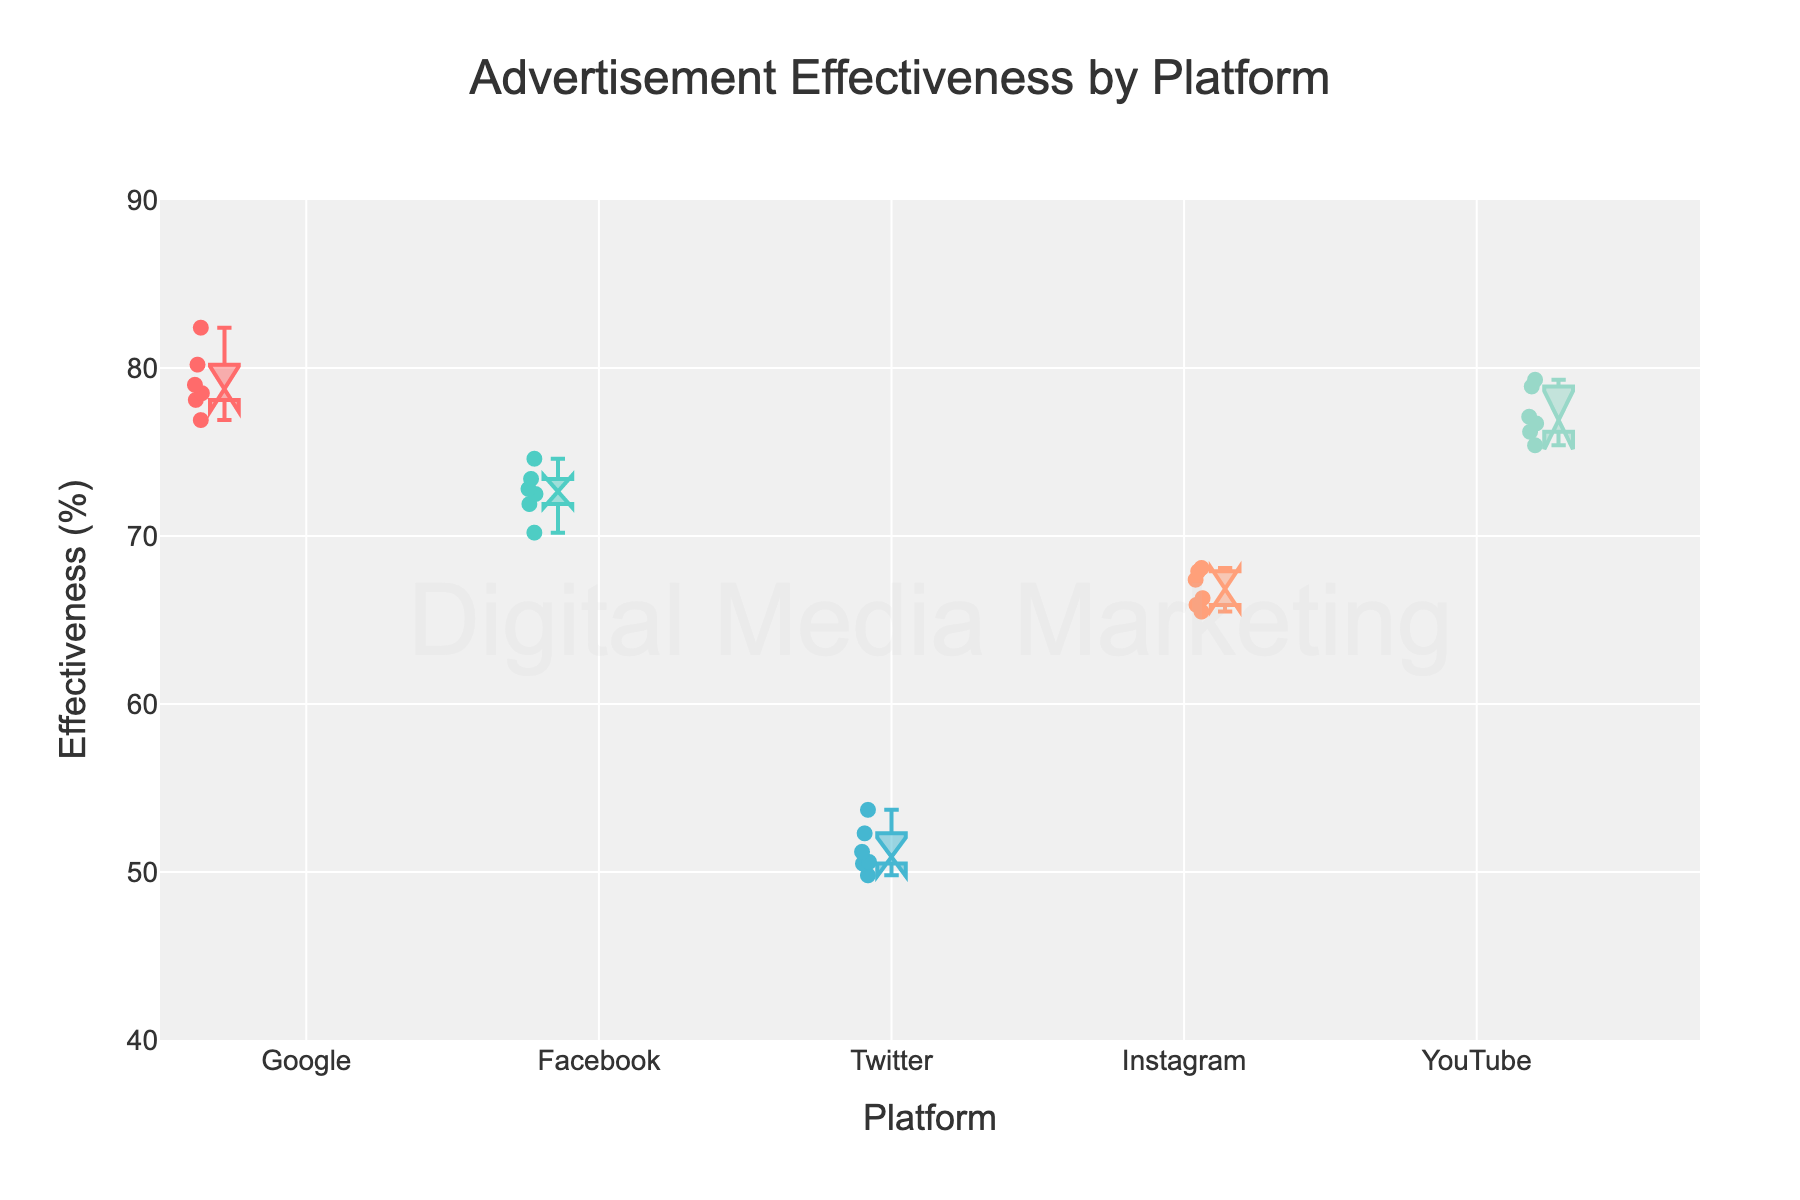Which platform has the highest median effectiveness? To identify the highest median effectiveness, look at the notches in the box plots. The notch represents the median. The platform with the highest notch is Google.
Answer: Google What is the range of effectiveness for Twitter? To find the range, look at the box plot for Twitter. The top whisker represents the maximum value, and the bottom whisker represents the minimum value. For Twitter, the minimum is approximately 49.8%, and the maximum is approximately 53.7%. Thus, the range is 53.7% - 49.8% = 3.9%.
Answer: 3.9% Which platform shows the most variability in effectiveness? The variability can be determined by looking at the Interquartile Range (IQR), which is the height of the box in the plot. The larger the IQR, the more variability. Facebook has the largest IQR, indicating the most variability.
Answer: Facebook Which platform's effectiveness has the least overlap with the others? The least overlap can be identified by the unique notched box plot that doesn't overlap with other notches. Google has the least overlap with other platforms, indicating its effectiveness is distinctly higher.
Answer: Google What is the effectiveness of Instagram's lower quartile (25th percentile)? The lower quartile (25th percentile) is represented by the bottom of the box in the plot. For Instagram, this value is approximately 65.9%.
Answer: 65.9% Which platform has the closest effectiveness median values to YouTube? Compare the medians by looking at the notches. Instagram's median effectiveness is closest to YouTube's median effectiveness.
Answer: Instagram How does Facebook's median effectiveness compare to Twitter's? Look at the notches for both Facebook and Twitter. Facebook's median is higher than Twitter's median effectiveness.
Answer: Facebook's median is higher What is the effectiveness value at the 75th percentile for YouTube? The 75th percentile (upper quartile) is represented by the top edge of the box. For YouTube, this value is approximately 78.9%.
Answer: 78.9% Which two platforms have the most similar range of effectiveness values? To identify similarity, compare the range (difference between the maximum and minimum) of each platform. Twitter and Instagram have the most similar range (3.2% and 2.6% respectively).
Answer: Twitter and Instagram What pattern do you see in the effectiveness of platforms with increasing advertisement spend? Higher advertisement spend seems generally correlated with higher median effectiveness, as seen with platforms like Google and YouTube having higher effectiveness at higher spend levels.
Answer: Positive correlation between spend and effectiveness 